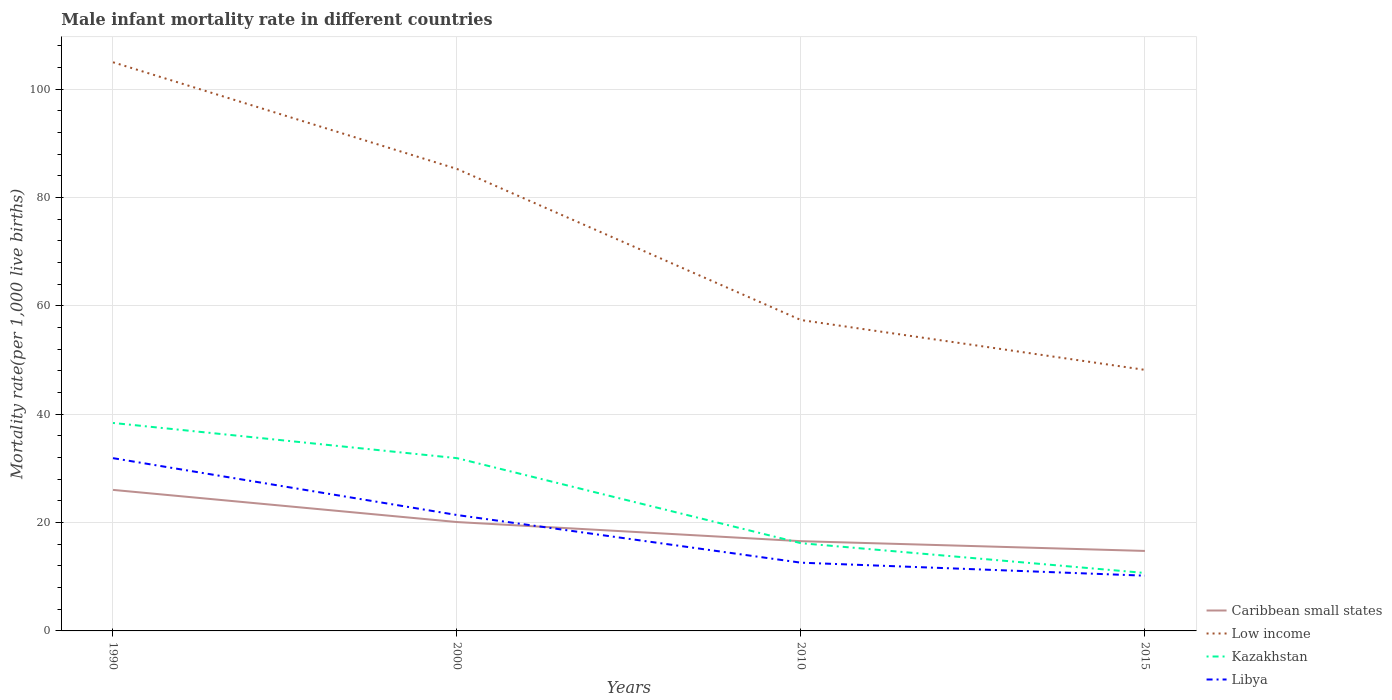Does the line corresponding to Libya intersect with the line corresponding to Kazakhstan?
Your answer should be compact. No. Is the number of lines equal to the number of legend labels?
Offer a terse response. Yes. In which year was the male infant mortality rate in Caribbean small states maximum?
Make the answer very short. 2015. What is the total male infant mortality rate in Caribbean small states in the graph?
Your answer should be very brief. 1.8. What is the difference between the highest and the second highest male infant mortality rate in Kazakhstan?
Your answer should be very brief. 27.7. What is the difference between the highest and the lowest male infant mortality rate in Low income?
Keep it short and to the point. 2. Are the values on the major ticks of Y-axis written in scientific E-notation?
Make the answer very short. No. What is the title of the graph?
Offer a terse response. Male infant mortality rate in different countries. What is the label or title of the X-axis?
Offer a terse response. Years. What is the label or title of the Y-axis?
Your response must be concise. Mortality rate(per 1,0 live births). What is the Mortality rate(per 1,000 live births) of Caribbean small states in 1990?
Provide a short and direct response. 26.04. What is the Mortality rate(per 1,000 live births) of Low income in 1990?
Give a very brief answer. 105. What is the Mortality rate(per 1,000 live births) of Kazakhstan in 1990?
Keep it short and to the point. 38.4. What is the Mortality rate(per 1,000 live births) of Libya in 1990?
Ensure brevity in your answer.  31.9. What is the Mortality rate(per 1,000 live births) in Caribbean small states in 2000?
Your response must be concise. 20.1. What is the Mortality rate(per 1,000 live births) in Low income in 2000?
Provide a short and direct response. 85.3. What is the Mortality rate(per 1,000 live births) in Kazakhstan in 2000?
Your answer should be compact. 31.9. What is the Mortality rate(per 1,000 live births) in Libya in 2000?
Provide a short and direct response. 21.4. What is the Mortality rate(per 1,000 live births) in Caribbean small states in 2010?
Ensure brevity in your answer.  16.57. What is the Mortality rate(per 1,000 live births) of Low income in 2010?
Your response must be concise. 57.4. What is the Mortality rate(per 1,000 live births) in Libya in 2010?
Provide a short and direct response. 12.6. What is the Mortality rate(per 1,000 live births) of Caribbean small states in 2015?
Your answer should be compact. 14.77. What is the Mortality rate(per 1,000 live births) of Low income in 2015?
Keep it short and to the point. 48.2. What is the Mortality rate(per 1,000 live births) in Kazakhstan in 2015?
Ensure brevity in your answer.  10.7. Across all years, what is the maximum Mortality rate(per 1,000 live births) in Caribbean small states?
Provide a short and direct response. 26.04. Across all years, what is the maximum Mortality rate(per 1,000 live births) in Low income?
Make the answer very short. 105. Across all years, what is the maximum Mortality rate(per 1,000 live births) in Kazakhstan?
Provide a succinct answer. 38.4. Across all years, what is the maximum Mortality rate(per 1,000 live births) of Libya?
Ensure brevity in your answer.  31.9. Across all years, what is the minimum Mortality rate(per 1,000 live births) in Caribbean small states?
Make the answer very short. 14.77. Across all years, what is the minimum Mortality rate(per 1,000 live births) in Low income?
Offer a terse response. 48.2. Across all years, what is the minimum Mortality rate(per 1,000 live births) in Kazakhstan?
Your answer should be compact. 10.7. What is the total Mortality rate(per 1,000 live births) of Caribbean small states in the graph?
Offer a terse response. 77.48. What is the total Mortality rate(per 1,000 live births) in Low income in the graph?
Offer a terse response. 295.9. What is the total Mortality rate(per 1,000 live births) in Kazakhstan in the graph?
Give a very brief answer. 97.2. What is the total Mortality rate(per 1,000 live births) of Libya in the graph?
Give a very brief answer. 76.1. What is the difference between the Mortality rate(per 1,000 live births) of Caribbean small states in 1990 and that in 2000?
Offer a very short reply. 5.94. What is the difference between the Mortality rate(per 1,000 live births) in Low income in 1990 and that in 2000?
Provide a short and direct response. 19.7. What is the difference between the Mortality rate(per 1,000 live births) in Libya in 1990 and that in 2000?
Offer a very short reply. 10.5. What is the difference between the Mortality rate(per 1,000 live births) of Caribbean small states in 1990 and that in 2010?
Give a very brief answer. 9.47. What is the difference between the Mortality rate(per 1,000 live births) of Low income in 1990 and that in 2010?
Your answer should be compact. 47.6. What is the difference between the Mortality rate(per 1,000 live births) of Kazakhstan in 1990 and that in 2010?
Give a very brief answer. 22.2. What is the difference between the Mortality rate(per 1,000 live births) of Libya in 1990 and that in 2010?
Ensure brevity in your answer.  19.3. What is the difference between the Mortality rate(per 1,000 live births) in Caribbean small states in 1990 and that in 2015?
Your answer should be very brief. 11.27. What is the difference between the Mortality rate(per 1,000 live births) in Low income in 1990 and that in 2015?
Make the answer very short. 56.8. What is the difference between the Mortality rate(per 1,000 live births) of Kazakhstan in 1990 and that in 2015?
Ensure brevity in your answer.  27.7. What is the difference between the Mortality rate(per 1,000 live births) in Libya in 1990 and that in 2015?
Provide a short and direct response. 21.7. What is the difference between the Mortality rate(per 1,000 live births) in Caribbean small states in 2000 and that in 2010?
Give a very brief answer. 3.53. What is the difference between the Mortality rate(per 1,000 live births) in Low income in 2000 and that in 2010?
Ensure brevity in your answer.  27.9. What is the difference between the Mortality rate(per 1,000 live births) in Kazakhstan in 2000 and that in 2010?
Your answer should be compact. 15.7. What is the difference between the Mortality rate(per 1,000 live births) in Libya in 2000 and that in 2010?
Your answer should be very brief. 8.8. What is the difference between the Mortality rate(per 1,000 live births) in Caribbean small states in 2000 and that in 2015?
Ensure brevity in your answer.  5.33. What is the difference between the Mortality rate(per 1,000 live births) in Low income in 2000 and that in 2015?
Your answer should be very brief. 37.1. What is the difference between the Mortality rate(per 1,000 live births) in Kazakhstan in 2000 and that in 2015?
Your answer should be very brief. 21.2. What is the difference between the Mortality rate(per 1,000 live births) of Caribbean small states in 2010 and that in 2015?
Keep it short and to the point. 1.8. What is the difference between the Mortality rate(per 1,000 live births) in Low income in 2010 and that in 2015?
Ensure brevity in your answer.  9.2. What is the difference between the Mortality rate(per 1,000 live births) in Libya in 2010 and that in 2015?
Offer a very short reply. 2.4. What is the difference between the Mortality rate(per 1,000 live births) in Caribbean small states in 1990 and the Mortality rate(per 1,000 live births) in Low income in 2000?
Make the answer very short. -59.26. What is the difference between the Mortality rate(per 1,000 live births) in Caribbean small states in 1990 and the Mortality rate(per 1,000 live births) in Kazakhstan in 2000?
Offer a terse response. -5.86. What is the difference between the Mortality rate(per 1,000 live births) of Caribbean small states in 1990 and the Mortality rate(per 1,000 live births) of Libya in 2000?
Your response must be concise. 4.64. What is the difference between the Mortality rate(per 1,000 live births) of Low income in 1990 and the Mortality rate(per 1,000 live births) of Kazakhstan in 2000?
Provide a succinct answer. 73.1. What is the difference between the Mortality rate(per 1,000 live births) of Low income in 1990 and the Mortality rate(per 1,000 live births) of Libya in 2000?
Ensure brevity in your answer.  83.6. What is the difference between the Mortality rate(per 1,000 live births) in Kazakhstan in 1990 and the Mortality rate(per 1,000 live births) in Libya in 2000?
Keep it short and to the point. 17. What is the difference between the Mortality rate(per 1,000 live births) in Caribbean small states in 1990 and the Mortality rate(per 1,000 live births) in Low income in 2010?
Keep it short and to the point. -31.36. What is the difference between the Mortality rate(per 1,000 live births) of Caribbean small states in 1990 and the Mortality rate(per 1,000 live births) of Kazakhstan in 2010?
Make the answer very short. 9.84. What is the difference between the Mortality rate(per 1,000 live births) in Caribbean small states in 1990 and the Mortality rate(per 1,000 live births) in Libya in 2010?
Give a very brief answer. 13.44. What is the difference between the Mortality rate(per 1,000 live births) of Low income in 1990 and the Mortality rate(per 1,000 live births) of Kazakhstan in 2010?
Provide a short and direct response. 88.8. What is the difference between the Mortality rate(per 1,000 live births) in Low income in 1990 and the Mortality rate(per 1,000 live births) in Libya in 2010?
Give a very brief answer. 92.4. What is the difference between the Mortality rate(per 1,000 live births) of Kazakhstan in 1990 and the Mortality rate(per 1,000 live births) of Libya in 2010?
Your answer should be very brief. 25.8. What is the difference between the Mortality rate(per 1,000 live births) of Caribbean small states in 1990 and the Mortality rate(per 1,000 live births) of Low income in 2015?
Your response must be concise. -22.16. What is the difference between the Mortality rate(per 1,000 live births) of Caribbean small states in 1990 and the Mortality rate(per 1,000 live births) of Kazakhstan in 2015?
Provide a succinct answer. 15.34. What is the difference between the Mortality rate(per 1,000 live births) in Caribbean small states in 1990 and the Mortality rate(per 1,000 live births) in Libya in 2015?
Offer a terse response. 15.84. What is the difference between the Mortality rate(per 1,000 live births) in Low income in 1990 and the Mortality rate(per 1,000 live births) in Kazakhstan in 2015?
Your answer should be very brief. 94.3. What is the difference between the Mortality rate(per 1,000 live births) of Low income in 1990 and the Mortality rate(per 1,000 live births) of Libya in 2015?
Provide a short and direct response. 94.8. What is the difference between the Mortality rate(per 1,000 live births) of Kazakhstan in 1990 and the Mortality rate(per 1,000 live births) of Libya in 2015?
Provide a short and direct response. 28.2. What is the difference between the Mortality rate(per 1,000 live births) of Caribbean small states in 2000 and the Mortality rate(per 1,000 live births) of Low income in 2010?
Your answer should be compact. -37.3. What is the difference between the Mortality rate(per 1,000 live births) of Caribbean small states in 2000 and the Mortality rate(per 1,000 live births) of Kazakhstan in 2010?
Keep it short and to the point. 3.9. What is the difference between the Mortality rate(per 1,000 live births) in Caribbean small states in 2000 and the Mortality rate(per 1,000 live births) in Libya in 2010?
Provide a succinct answer. 7.5. What is the difference between the Mortality rate(per 1,000 live births) in Low income in 2000 and the Mortality rate(per 1,000 live births) in Kazakhstan in 2010?
Provide a succinct answer. 69.1. What is the difference between the Mortality rate(per 1,000 live births) of Low income in 2000 and the Mortality rate(per 1,000 live births) of Libya in 2010?
Offer a very short reply. 72.7. What is the difference between the Mortality rate(per 1,000 live births) of Kazakhstan in 2000 and the Mortality rate(per 1,000 live births) of Libya in 2010?
Ensure brevity in your answer.  19.3. What is the difference between the Mortality rate(per 1,000 live births) of Caribbean small states in 2000 and the Mortality rate(per 1,000 live births) of Low income in 2015?
Provide a succinct answer. -28.1. What is the difference between the Mortality rate(per 1,000 live births) of Caribbean small states in 2000 and the Mortality rate(per 1,000 live births) of Kazakhstan in 2015?
Provide a short and direct response. 9.4. What is the difference between the Mortality rate(per 1,000 live births) in Caribbean small states in 2000 and the Mortality rate(per 1,000 live births) in Libya in 2015?
Make the answer very short. 9.9. What is the difference between the Mortality rate(per 1,000 live births) of Low income in 2000 and the Mortality rate(per 1,000 live births) of Kazakhstan in 2015?
Provide a succinct answer. 74.6. What is the difference between the Mortality rate(per 1,000 live births) of Low income in 2000 and the Mortality rate(per 1,000 live births) of Libya in 2015?
Your answer should be very brief. 75.1. What is the difference between the Mortality rate(per 1,000 live births) in Kazakhstan in 2000 and the Mortality rate(per 1,000 live births) in Libya in 2015?
Your answer should be very brief. 21.7. What is the difference between the Mortality rate(per 1,000 live births) in Caribbean small states in 2010 and the Mortality rate(per 1,000 live births) in Low income in 2015?
Provide a short and direct response. -31.63. What is the difference between the Mortality rate(per 1,000 live births) in Caribbean small states in 2010 and the Mortality rate(per 1,000 live births) in Kazakhstan in 2015?
Provide a short and direct response. 5.87. What is the difference between the Mortality rate(per 1,000 live births) of Caribbean small states in 2010 and the Mortality rate(per 1,000 live births) of Libya in 2015?
Ensure brevity in your answer.  6.37. What is the difference between the Mortality rate(per 1,000 live births) of Low income in 2010 and the Mortality rate(per 1,000 live births) of Kazakhstan in 2015?
Provide a short and direct response. 46.7. What is the difference between the Mortality rate(per 1,000 live births) of Low income in 2010 and the Mortality rate(per 1,000 live births) of Libya in 2015?
Make the answer very short. 47.2. What is the average Mortality rate(per 1,000 live births) in Caribbean small states per year?
Make the answer very short. 19.37. What is the average Mortality rate(per 1,000 live births) in Low income per year?
Offer a very short reply. 73.97. What is the average Mortality rate(per 1,000 live births) of Kazakhstan per year?
Make the answer very short. 24.3. What is the average Mortality rate(per 1,000 live births) in Libya per year?
Offer a very short reply. 19.02. In the year 1990, what is the difference between the Mortality rate(per 1,000 live births) of Caribbean small states and Mortality rate(per 1,000 live births) of Low income?
Offer a very short reply. -78.96. In the year 1990, what is the difference between the Mortality rate(per 1,000 live births) of Caribbean small states and Mortality rate(per 1,000 live births) of Kazakhstan?
Make the answer very short. -12.36. In the year 1990, what is the difference between the Mortality rate(per 1,000 live births) in Caribbean small states and Mortality rate(per 1,000 live births) in Libya?
Offer a terse response. -5.86. In the year 1990, what is the difference between the Mortality rate(per 1,000 live births) in Low income and Mortality rate(per 1,000 live births) in Kazakhstan?
Offer a very short reply. 66.6. In the year 1990, what is the difference between the Mortality rate(per 1,000 live births) in Low income and Mortality rate(per 1,000 live births) in Libya?
Offer a terse response. 73.1. In the year 1990, what is the difference between the Mortality rate(per 1,000 live births) of Kazakhstan and Mortality rate(per 1,000 live births) of Libya?
Keep it short and to the point. 6.5. In the year 2000, what is the difference between the Mortality rate(per 1,000 live births) in Caribbean small states and Mortality rate(per 1,000 live births) in Low income?
Offer a very short reply. -65.2. In the year 2000, what is the difference between the Mortality rate(per 1,000 live births) of Caribbean small states and Mortality rate(per 1,000 live births) of Kazakhstan?
Provide a succinct answer. -11.8. In the year 2000, what is the difference between the Mortality rate(per 1,000 live births) of Caribbean small states and Mortality rate(per 1,000 live births) of Libya?
Provide a short and direct response. -1.3. In the year 2000, what is the difference between the Mortality rate(per 1,000 live births) in Low income and Mortality rate(per 1,000 live births) in Kazakhstan?
Your answer should be very brief. 53.4. In the year 2000, what is the difference between the Mortality rate(per 1,000 live births) of Low income and Mortality rate(per 1,000 live births) of Libya?
Make the answer very short. 63.9. In the year 2000, what is the difference between the Mortality rate(per 1,000 live births) in Kazakhstan and Mortality rate(per 1,000 live births) in Libya?
Ensure brevity in your answer.  10.5. In the year 2010, what is the difference between the Mortality rate(per 1,000 live births) in Caribbean small states and Mortality rate(per 1,000 live births) in Low income?
Your answer should be very brief. -40.83. In the year 2010, what is the difference between the Mortality rate(per 1,000 live births) of Caribbean small states and Mortality rate(per 1,000 live births) of Kazakhstan?
Make the answer very short. 0.37. In the year 2010, what is the difference between the Mortality rate(per 1,000 live births) in Caribbean small states and Mortality rate(per 1,000 live births) in Libya?
Provide a short and direct response. 3.97. In the year 2010, what is the difference between the Mortality rate(per 1,000 live births) in Low income and Mortality rate(per 1,000 live births) in Kazakhstan?
Your response must be concise. 41.2. In the year 2010, what is the difference between the Mortality rate(per 1,000 live births) in Low income and Mortality rate(per 1,000 live births) in Libya?
Offer a terse response. 44.8. In the year 2015, what is the difference between the Mortality rate(per 1,000 live births) in Caribbean small states and Mortality rate(per 1,000 live births) in Low income?
Provide a short and direct response. -33.43. In the year 2015, what is the difference between the Mortality rate(per 1,000 live births) of Caribbean small states and Mortality rate(per 1,000 live births) of Kazakhstan?
Offer a terse response. 4.07. In the year 2015, what is the difference between the Mortality rate(per 1,000 live births) in Caribbean small states and Mortality rate(per 1,000 live births) in Libya?
Your answer should be very brief. 4.57. In the year 2015, what is the difference between the Mortality rate(per 1,000 live births) of Low income and Mortality rate(per 1,000 live births) of Kazakhstan?
Keep it short and to the point. 37.5. In the year 2015, what is the difference between the Mortality rate(per 1,000 live births) of Low income and Mortality rate(per 1,000 live births) of Libya?
Your answer should be very brief. 38. What is the ratio of the Mortality rate(per 1,000 live births) of Caribbean small states in 1990 to that in 2000?
Your response must be concise. 1.3. What is the ratio of the Mortality rate(per 1,000 live births) in Low income in 1990 to that in 2000?
Make the answer very short. 1.23. What is the ratio of the Mortality rate(per 1,000 live births) in Kazakhstan in 1990 to that in 2000?
Give a very brief answer. 1.2. What is the ratio of the Mortality rate(per 1,000 live births) in Libya in 1990 to that in 2000?
Offer a very short reply. 1.49. What is the ratio of the Mortality rate(per 1,000 live births) of Caribbean small states in 1990 to that in 2010?
Make the answer very short. 1.57. What is the ratio of the Mortality rate(per 1,000 live births) in Low income in 1990 to that in 2010?
Your response must be concise. 1.83. What is the ratio of the Mortality rate(per 1,000 live births) in Kazakhstan in 1990 to that in 2010?
Provide a succinct answer. 2.37. What is the ratio of the Mortality rate(per 1,000 live births) in Libya in 1990 to that in 2010?
Provide a short and direct response. 2.53. What is the ratio of the Mortality rate(per 1,000 live births) of Caribbean small states in 1990 to that in 2015?
Make the answer very short. 1.76. What is the ratio of the Mortality rate(per 1,000 live births) of Low income in 1990 to that in 2015?
Make the answer very short. 2.18. What is the ratio of the Mortality rate(per 1,000 live births) of Kazakhstan in 1990 to that in 2015?
Give a very brief answer. 3.59. What is the ratio of the Mortality rate(per 1,000 live births) in Libya in 1990 to that in 2015?
Provide a succinct answer. 3.13. What is the ratio of the Mortality rate(per 1,000 live births) of Caribbean small states in 2000 to that in 2010?
Provide a short and direct response. 1.21. What is the ratio of the Mortality rate(per 1,000 live births) of Low income in 2000 to that in 2010?
Your response must be concise. 1.49. What is the ratio of the Mortality rate(per 1,000 live births) of Kazakhstan in 2000 to that in 2010?
Give a very brief answer. 1.97. What is the ratio of the Mortality rate(per 1,000 live births) in Libya in 2000 to that in 2010?
Your answer should be very brief. 1.7. What is the ratio of the Mortality rate(per 1,000 live births) in Caribbean small states in 2000 to that in 2015?
Your response must be concise. 1.36. What is the ratio of the Mortality rate(per 1,000 live births) in Low income in 2000 to that in 2015?
Offer a terse response. 1.77. What is the ratio of the Mortality rate(per 1,000 live births) of Kazakhstan in 2000 to that in 2015?
Your answer should be compact. 2.98. What is the ratio of the Mortality rate(per 1,000 live births) of Libya in 2000 to that in 2015?
Make the answer very short. 2.1. What is the ratio of the Mortality rate(per 1,000 live births) in Caribbean small states in 2010 to that in 2015?
Offer a terse response. 1.12. What is the ratio of the Mortality rate(per 1,000 live births) of Low income in 2010 to that in 2015?
Your answer should be very brief. 1.19. What is the ratio of the Mortality rate(per 1,000 live births) of Kazakhstan in 2010 to that in 2015?
Offer a very short reply. 1.51. What is the ratio of the Mortality rate(per 1,000 live births) of Libya in 2010 to that in 2015?
Give a very brief answer. 1.24. What is the difference between the highest and the second highest Mortality rate(per 1,000 live births) of Caribbean small states?
Your answer should be compact. 5.94. What is the difference between the highest and the second highest Mortality rate(per 1,000 live births) of Kazakhstan?
Provide a short and direct response. 6.5. What is the difference between the highest and the second highest Mortality rate(per 1,000 live births) of Libya?
Your answer should be very brief. 10.5. What is the difference between the highest and the lowest Mortality rate(per 1,000 live births) in Caribbean small states?
Ensure brevity in your answer.  11.27. What is the difference between the highest and the lowest Mortality rate(per 1,000 live births) of Low income?
Make the answer very short. 56.8. What is the difference between the highest and the lowest Mortality rate(per 1,000 live births) in Kazakhstan?
Your response must be concise. 27.7. What is the difference between the highest and the lowest Mortality rate(per 1,000 live births) in Libya?
Provide a succinct answer. 21.7. 